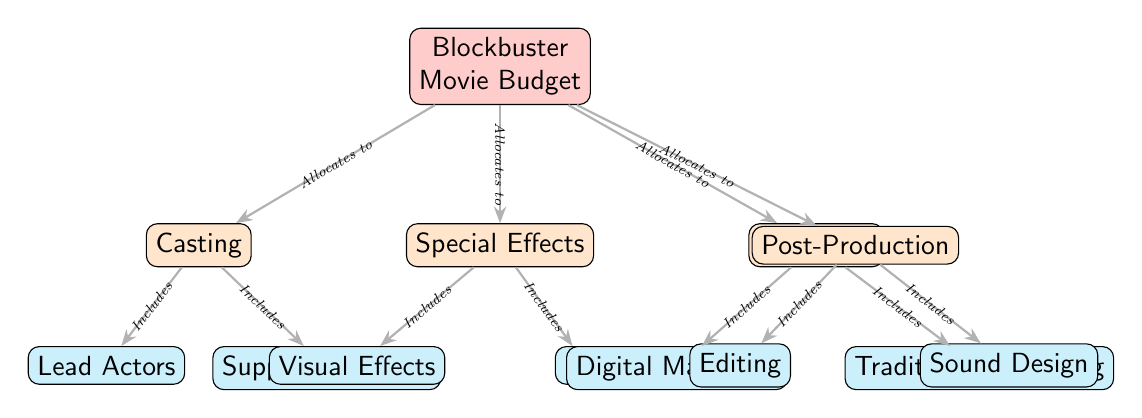What is the main category of the budget? The diagram states “Blockbuster Movie Budget” at the top, indicating that this is the central theme of the budget allocation being discussed.
Answer: Blockbuster Movie Budget How many main categories are shown in the diagram? The diagram lists four main categories connected to the central node: Casting, Special Effects, Marketing, and Post-Production. Counting these gives a total of four categories.
Answer: Four What are the two subcategories under Casting? The diagram indicates that the Casting category includes Lead Actors and Supporting Actors. These are explicitly listed under the Casting node.
Answer: Lead Actors, Supporting Actors Which category includes visual effects? The diagram shows that visual effects are part of the Special Effects category, as indicated by the directed edge labeled “Includes” from Special Effects to Visual Effects.
Answer: Special Effects What is the relationship between Casting and its subcategories? The relationship is indicated in the diagram by an edge labeled "Includes," showing that Casting allocates funds to its subcategories, Lead Actors and Supporting Actors.
Answer: Casting includes Lead Actors, Supporting Actors How many subcategories fall under Marketing? The Marketing category in the diagram divides into Digital Marketing and Traditional Marketing, which totals two subcategories.
Answer: Two Which category allocates budget for sound design? The budget for Sound Design is allocated under the Post-Production category, as identified in the diagram.
Answer: Post-Production What type of edges are shown connecting the main nodes to their respective subcategories? The edges connecting main nodes to their subcategories are labeled “Includes,” indicating that these subcategories are components of the main categories.
Answer: Includes How does the diagram categorize the different areas of spending? The diagram categorizes spending into distinct hierarchical levels, starting from the main node (Blockbuster Movie Budget) down to specific subcategories, specifying how the budget is divided.
Answer: Hierarchical categories 